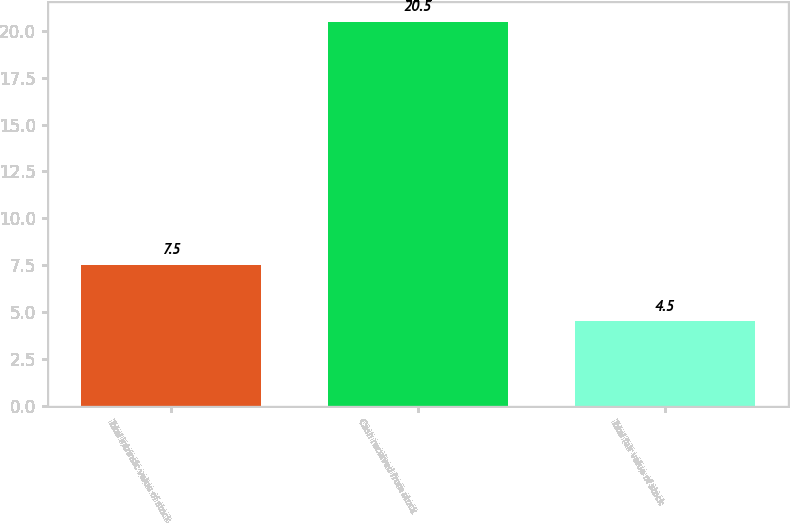Convert chart to OTSL. <chart><loc_0><loc_0><loc_500><loc_500><bar_chart><fcel>Total intrinsic value of stock<fcel>Cash received from stock<fcel>Total fair value of stock<nl><fcel>7.5<fcel>20.5<fcel>4.5<nl></chart> 